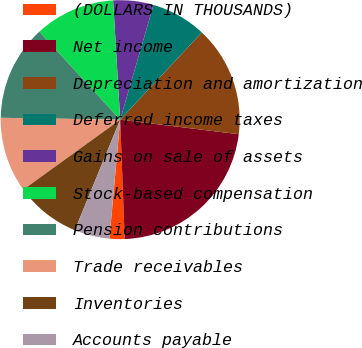<chart> <loc_0><loc_0><loc_500><loc_500><pie_chart><fcel>(DOLLARS IN THOUSANDS)<fcel>Net income<fcel>Depreciation and amortization<fcel>Deferred income taxes<fcel>Gains on sale of assets<fcel>Stock-based compensation<fcel>Pension contributions<fcel>Trade receivables<fcel>Inventories<fcel>Accounts payable<nl><fcel>2.04%<fcel>22.44%<fcel>14.96%<fcel>7.48%<fcel>5.44%<fcel>10.88%<fcel>12.92%<fcel>10.2%<fcel>8.84%<fcel>4.76%<nl></chart> 